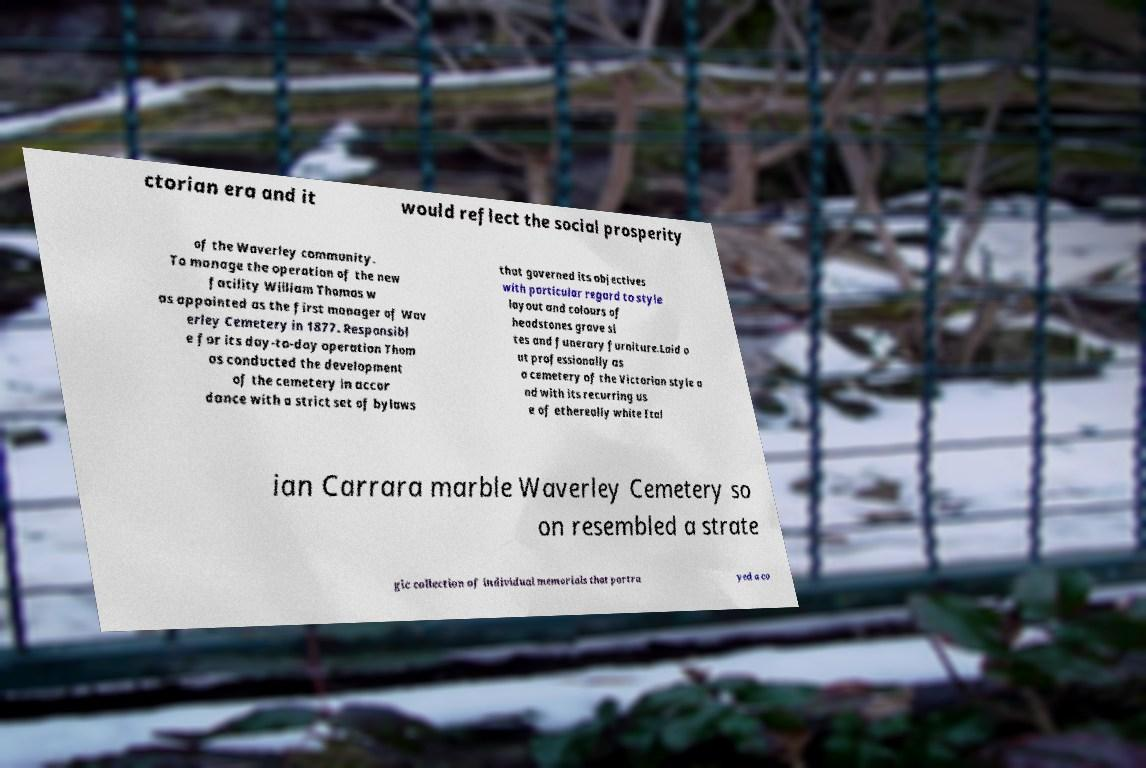Can you read and provide the text displayed in the image?This photo seems to have some interesting text. Can you extract and type it out for me? ctorian era and it would reflect the social prosperity of the Waverley community. To manage the operation of the new facility William Thomas w as appointed as the first manager of Wav erley Cemetery in 1877. Responsibl e for its day-to-day operation Thom as conducted the development of the cemetery in accor dance with a strict set of bylaws that governed its objectives with particular regard to style layout and colours of headstones grave si tes and funerary furniture.Laid o ut professionally as a cemetery of the Victorian style a nd with its recurring us e of ethereally white Ital ian Carrara marble Waverley Cemetery so on resembled a strate gic collection of individual memorials that portra yed a co 